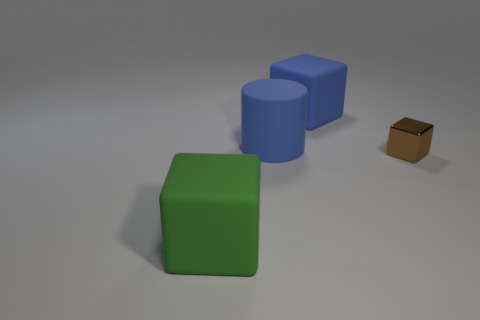What number of yellow things are small blocks or big cylinders?
Your answer should be compact. 0. Is there a blue cylinder of the same size as the green matte object?
Give a very brief answer. Yes. What is the blue thing behind the big blue rubber object left of the big blue rubber object to the right of the blue cylinder made of?
Ensure brevity in your answer.  Rubber. Are there the same number of green matte cubes on the left side of the green matte thing and cubes?
Your answer should be compact. No. Are the brown object that is behind the green block and the big cube that is behind the brown thing made of the same material?
Your response must be concise. No. How many things are large objects or big things that are behind the big green thing?
Offer a terse response. 3. Are there any small shiny things of the same shape as the green matte thing?
Ensure brevity in your answer.  Yes. There is a matte block to the right of the thing that is to the left of the blue matte thing in front of the large blue matte cube; what is its size?
Keep it short and to the point. Large. Are there an equal number of large green rubber objects right of the brown thing and cylinders that are on the right side of the large cylinder?
Provide a short and direct response. Yes. The green thing that is the same material as the cylinder is what size?
Ensure brevity in your answer.  Large. 